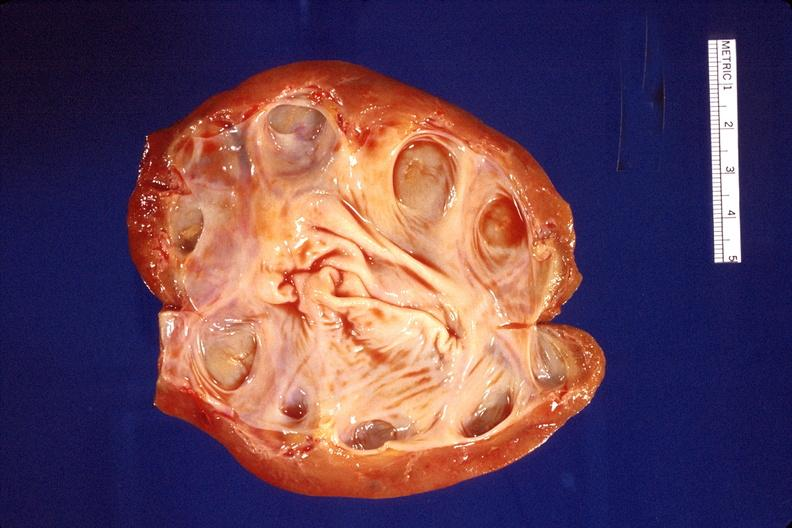what does this image show?
Answer the question using a single word or phrase. Kidney 